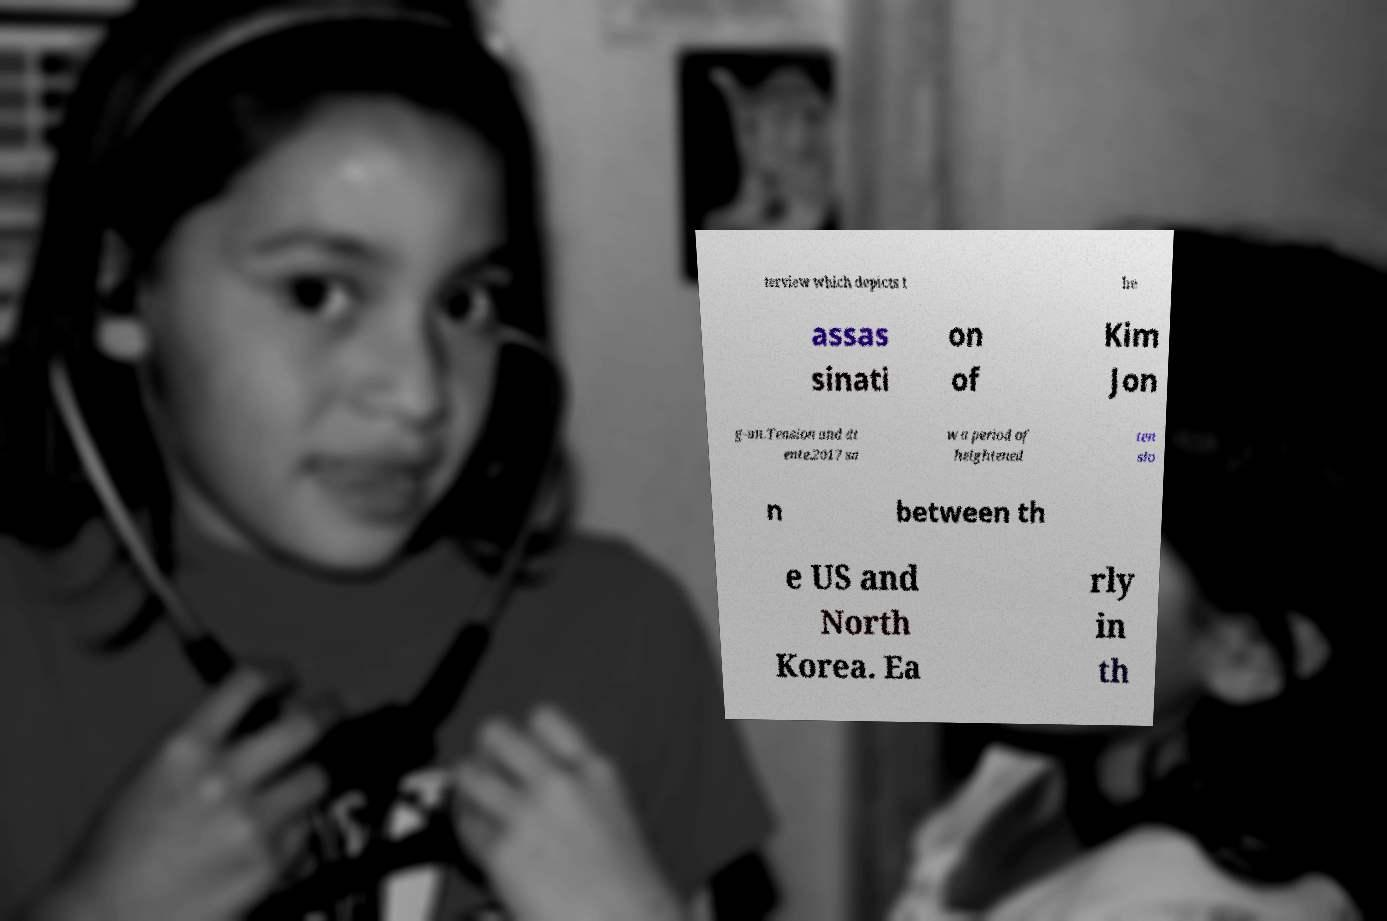Could you extract and type out the text from this image? terview which depicts t he assas sinati on of Kim Jon g-un.Tension and dt ente.2017 sa w a period of heightened ten sio n between th e US and North Korea. Ea rly in th 